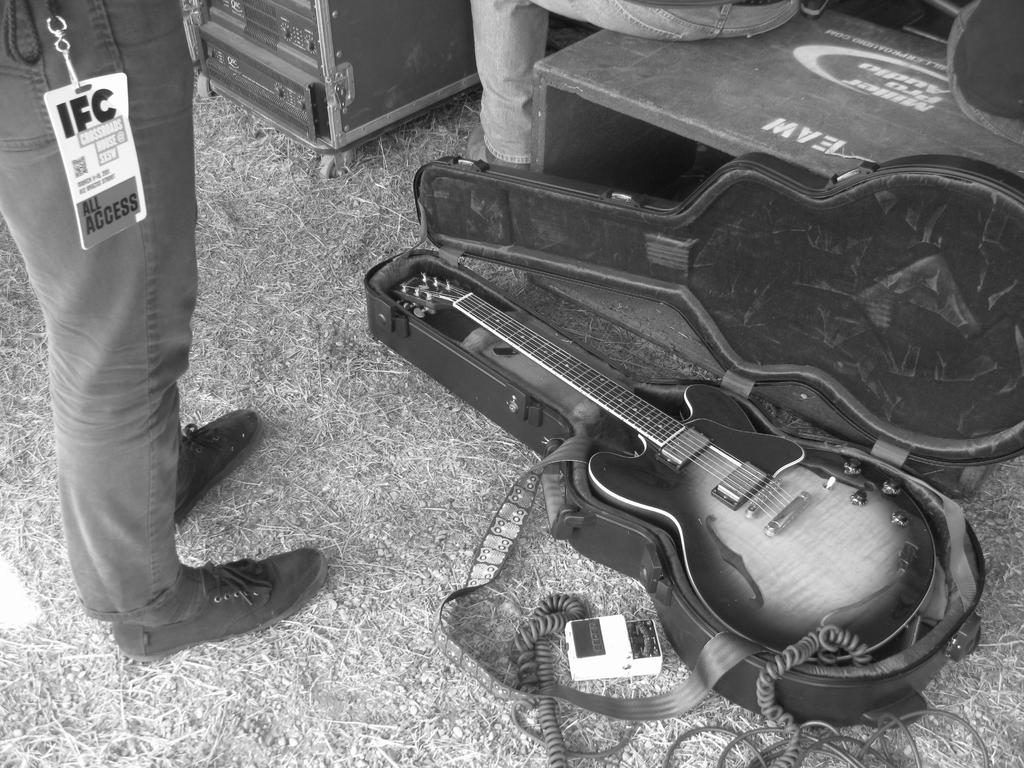What is the primary subject of the image? There is a person standing in the image. What is the person wearing on their feet? The person is wearing shoes. What object can be seen in the image besides the person? There is a guitar in the image. How is the guitar being protected or stored? The guitar has a cover. What is the position of the second person in the image? There is a person sitting in the image. How many pigs are visible in the image? There are no pigs present in the image. Can you describe the bite marks on the guitar in the image? There are no bite marks on the guitar in the image, as it is covered by a protective cover. 